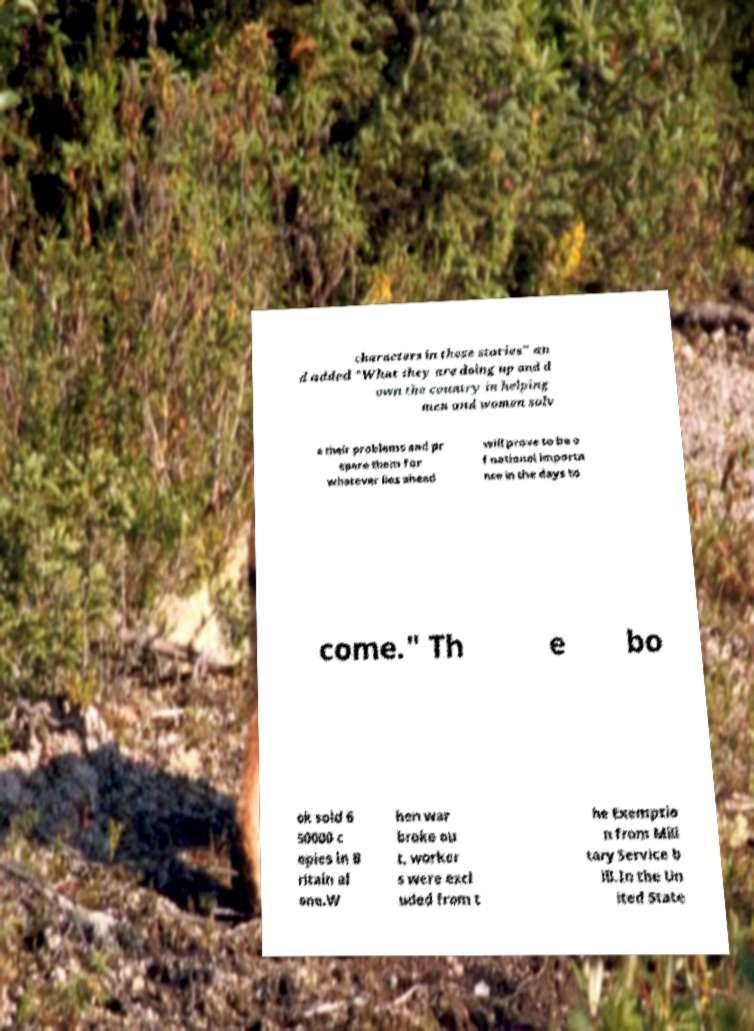I need the written content from this picture converted into text. Can you do that? characters in these stories" an d added "What they are doing up and d own the country in helping men and women solv e their problems and pr epare them for whatever lies ahead will prove to be o f national importa nce in the days to come." Th e bo ok sold 6 50000 c opies in B ritain al one.W hen war broke ou t, worker s were excl uded from t he Exemptio n from Mili tary Service b ill.In the Un ited State 